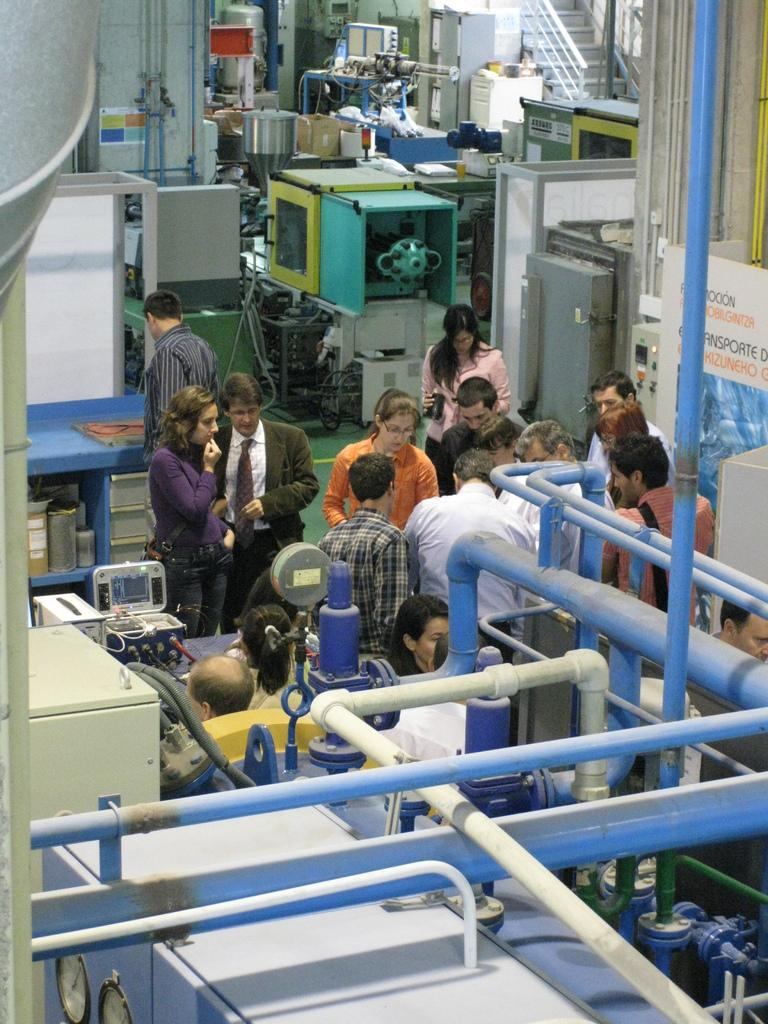What can be seen at the front of the image? There are pipes in the front of the image. What is happening in the center of the image? There are persons standing in the center of the image. What is visible in the background of the image? There are machines in the background of the image. Can you tell me how many cacti are present in the image? There are no cacti present in the image; it features pipes, persons, and machines. What type of dock is visible in the image? There is no dock present in the image. 